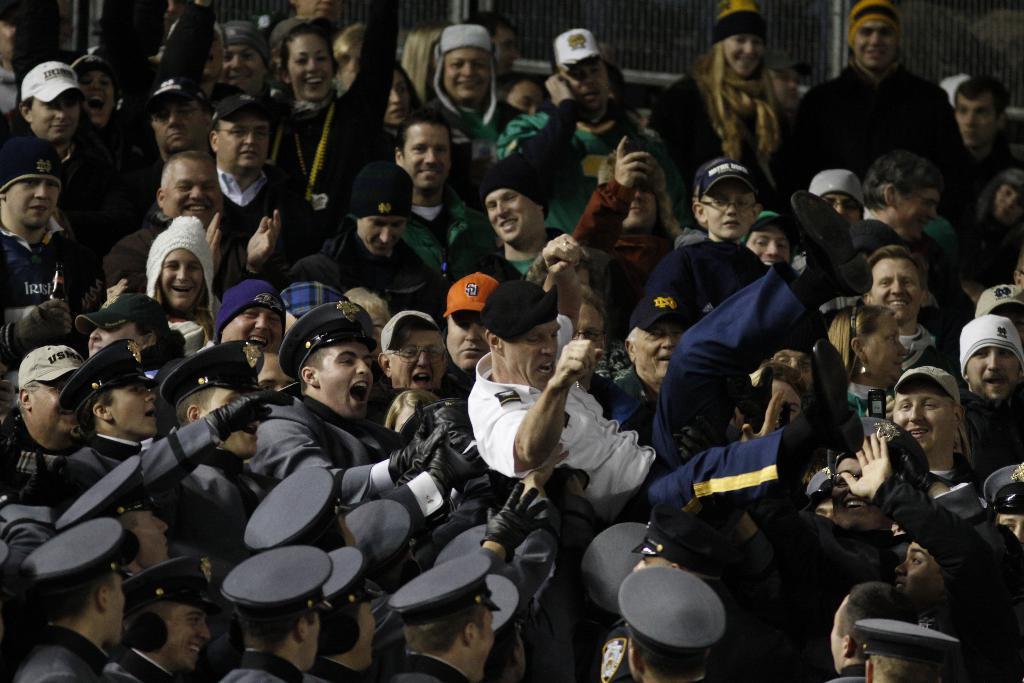Please provide a concise description of this image. In this image there are group of persons, there are persons wearing caps, there are persons holding an object, there is a fencing towards the top of the image. 